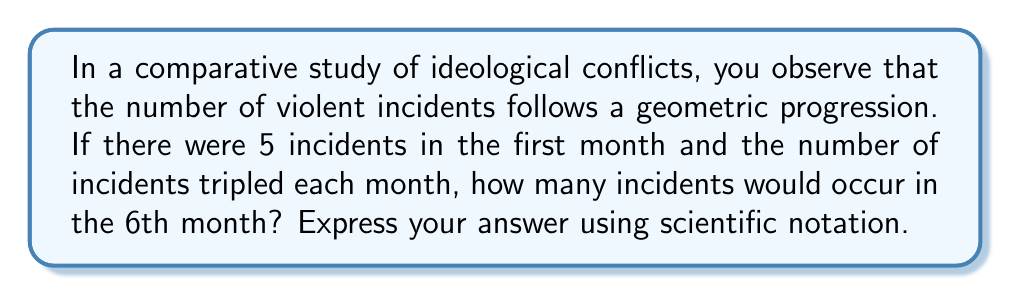Show me your answer to this math problem. Let's approach this step-by-step:

1) In a geometric progression, each term is a constant multiple of the previous term. Here, the constant (common ratio) is 3, as the number of incidents triples each month.

2) We can represent this geometric progression as:

   $a_n = a_1 \cdot r^{n-1}$

   Where:
   $a_n$ is the number of incidents in the nth month
   $a_1$ is the initial number of incidents (5)
   $r$ is the common ratio (3)
   $n$ is the month number

3) We want to find $a_6$, so we plug in our values:

   $a_6 = 5 \cdot 3^{6-1} = 5 \cdot 3^5$

4) Let's calculate this:

   $5 \cdot 3^5 = 5 \cdot 243 = 1,215$

5) To express this in scientific notation, we move the decimal point to be after the first non-zero digit and adjust the exponent:

   $1,215 = 1.215 \times 10^3$

Therefore, in the 6th month, there would be $1.215 \times 10^3$ incidents.
Answer: $1.215 \times 10^3$ 